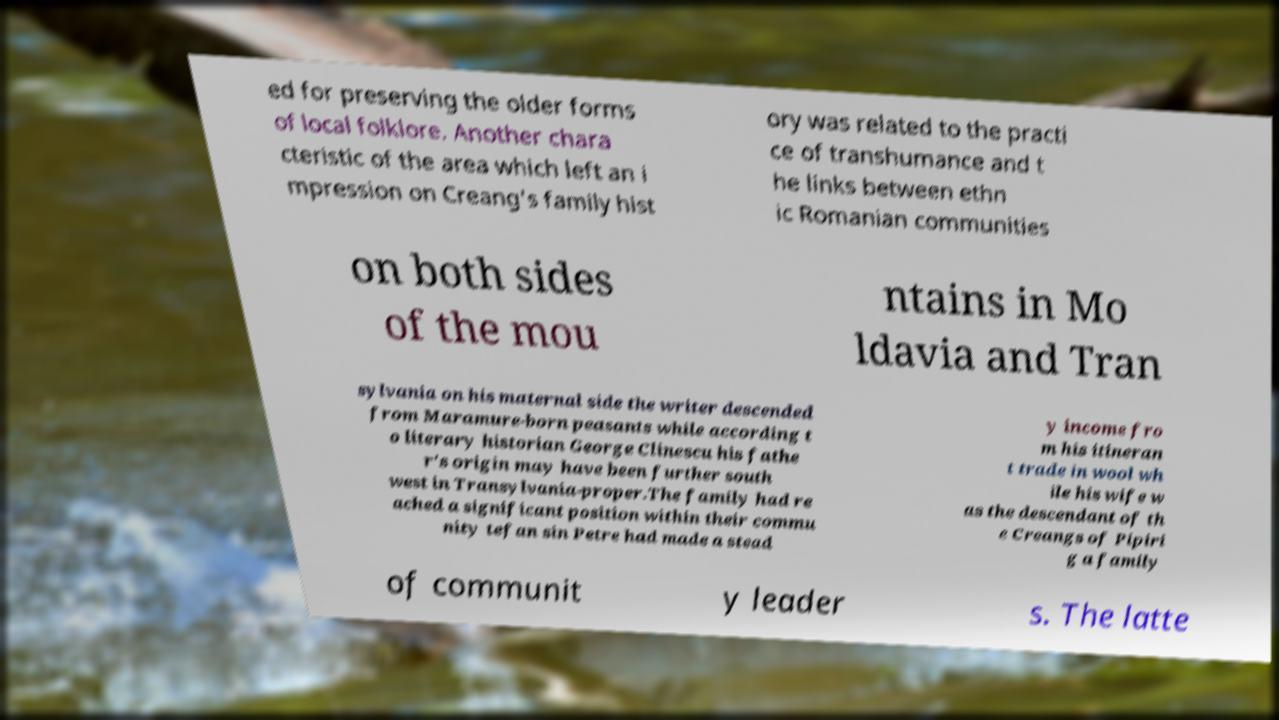There's text embedded in this image that I need extracted. Can you transcribe it verbatim? ed for preserving the older forms of local folklore. Another chara cteristic of the area which left an i mpression on Creang's family hist ory was related to the practi ce of transhumance and t he links between ethn ic Romanian communities on both sides of the mou ntains in Mo ldavia and Tran sylvania on his maternal side the writer descended from Maramure-born peasants while according t o literary historian George Clinescu his fathe r's origin may have been further south west in Transylvania-proper.The family had re ached a significant position within their commu nity tefan sin Petre had made a stead y income fro m his itineran t trade in wool wh ile his wife w as the descendant of th e Creangs of Pipiri g a family of communit y leader s. The latte 